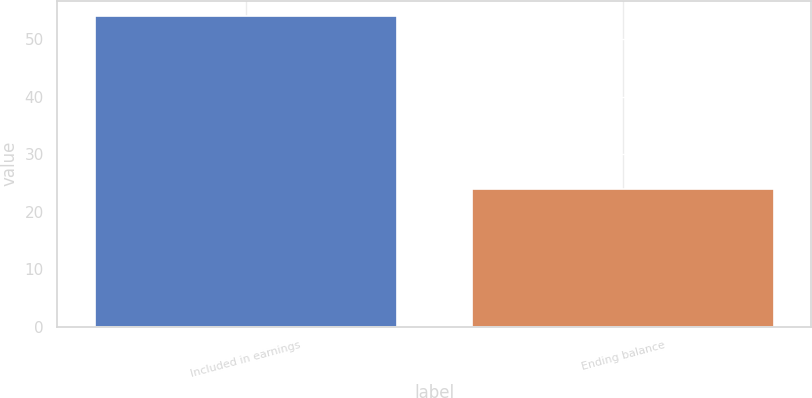<chart> <loc_0><loc_0><loc_500><loc_500><bar_chart><fcel>Included in earnings<fcel>Ending balance<nl><fcel>54<fcel>24<nl></chart> 